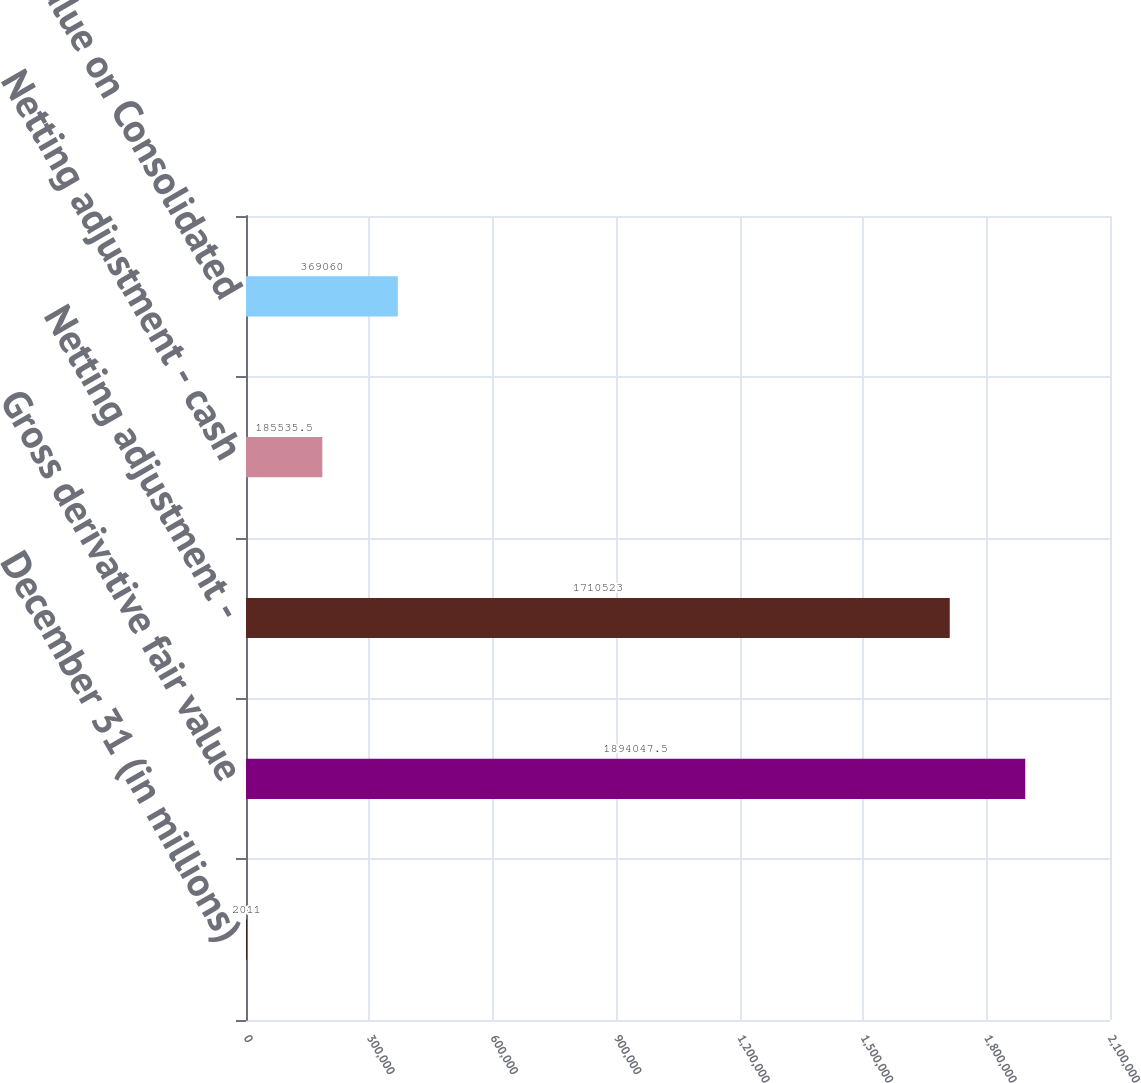Convert chart to OTSL. <chart><loc_0><loc_0><loc_500><loc_500><bar_chart><fcel>December 31 (in millions)<fcel>Gross derivative fair value<fcel>Netting adjustment -<fcel>Netting adjustment - cash<fcel>Carrying value on Consolidated<nl><fcel>2011<fcel>1.89405e+06<fcel>1.71052e+06<fcel>185536<fcel>369060<nl></chart> 